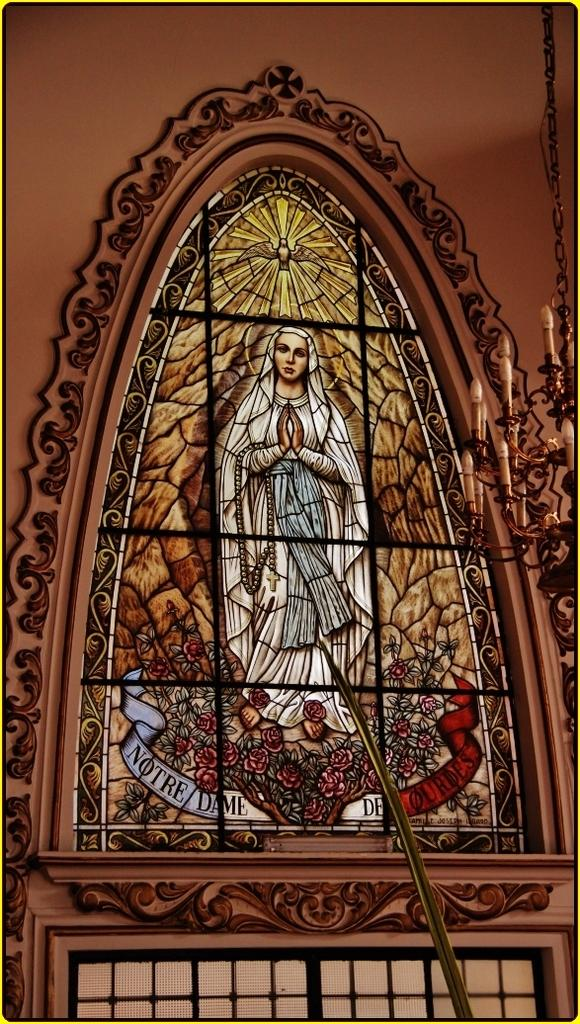What type of wall can be seen in the image? There is a designed wall in the image. What lighting fixture is present in the image? There is a chandelier in the image. What cooking appliance is visible in the image? There is a grill in the image. What type of store can be seen in the image? There is no store present in the image; it features a designed wall, chandelier, and grill. What holiday is being celebrated in the image? There is no indication of a holiday being celebrated in the image. 